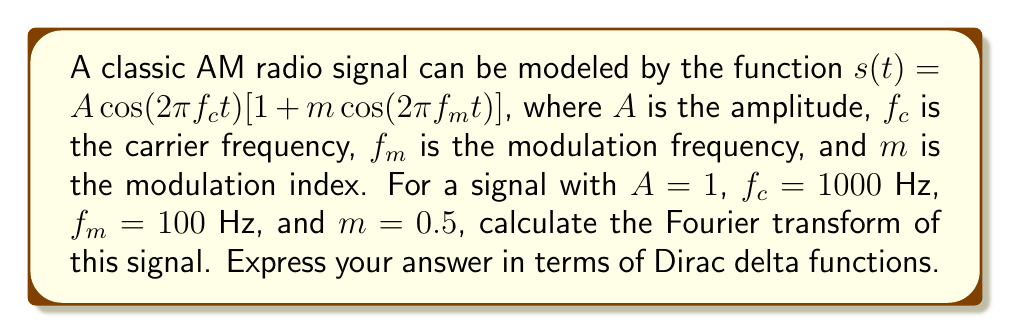What is the answer to this math problem? Let's approach this step-by-step:

1) First, we expand the given function:
   $$s(t) = A\cos(2\pi f_c t) + Am\cos(2\pi f_c t)\cos(2\pi f_m t)$$

2) Using the trigonometric identity $\cos(a)\cos(b) = \frac{1}{2}[\cos(a-b) + \cos(a+b)]$, we get:
   $$s(t) = \cos(2\pi \cdot 1000t) + 0.25[\cos(2\pi \cdot 900t) + \cos(2\pi \cdot 1100t)]$$

3) Now, we know that the Fourier transform of $\cos(\omega t)$ is:
   $$\mathcal{F}\{\cos(\omega t)\} = \frac{1}{2}[\delta(f - \frac{\omega}{2\pi}) + \delta(f + \frac{\omega}{2\pi})]$$

4) Applying this to each term:
   
   For $\cos(2\pi \cdot 1000t)$:
   $$\frac{1}{2}[\delta(f - 1000) + \delta(f + 1000)]$$
   
   For $0.25\cos(2\pi \cdot 900t)$:
   $$\frac{1}{8}[\delta(f - 900) + \delta(f + 900)]$$
   
   For $0.25\cos(2\pi \cdot 1100t)$:
   $$\frac{1}{8}[\delta(f - 1100) + \delta(f + 1100)]$$

5) The Fourier transform of the sum is the sum of the Fourier transforms, so we add these together:

   $$S(f) = \frac{1}{2}[\delta(f - 1000) + \delta(f + 1000)] + \frac{1}{8}[\delta(f - 900) + \delta(f + 900)] + \frac{1}{8}[\delta(f - 1100) + \delta(f + 1100)]$$

This is the Fourier transform of the given AM radio signal.
Answer: $$S(f) = \frac{1}{2}[\delta(f \pm 1000)] + \frac{1}{8}[\delta(f \pm 900) + \delta(f \pm 1100)]$$ 